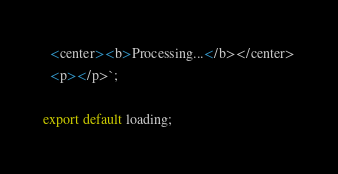<code> <loc_0><loc_0><loc_500><loc_500><_JavaScript_>  <center><b>Processing...</b></center>
  <p></p>`;

export default loading;
</code> 